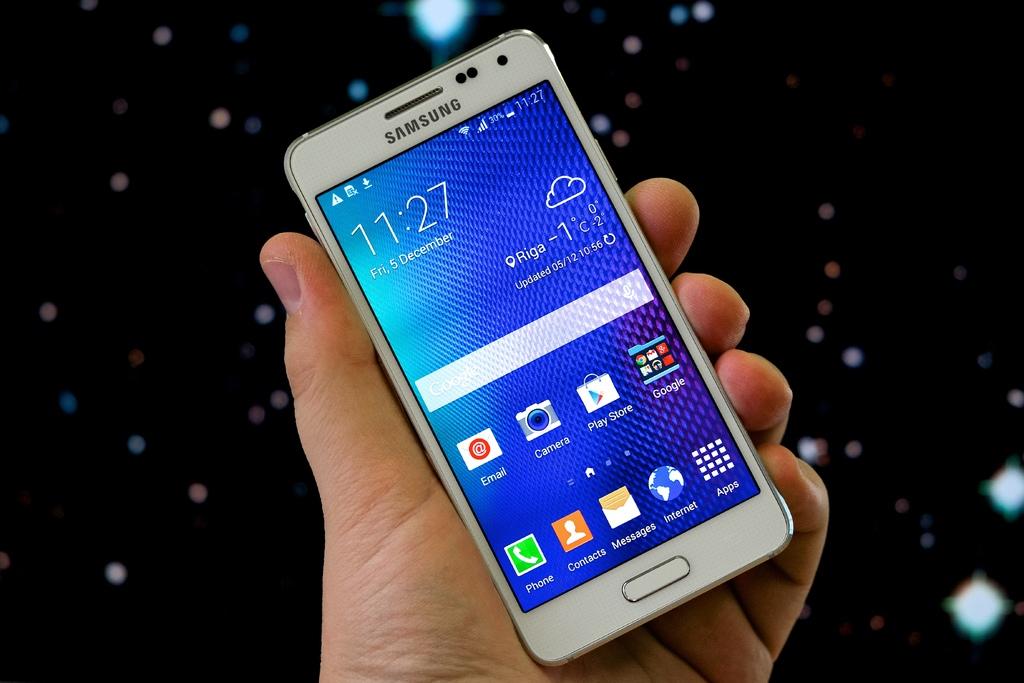What is the date on this phone?
Offer a very short reply. 5 december. What is the temperature displayed on the screen?
Your answer should be compact. -1c. 